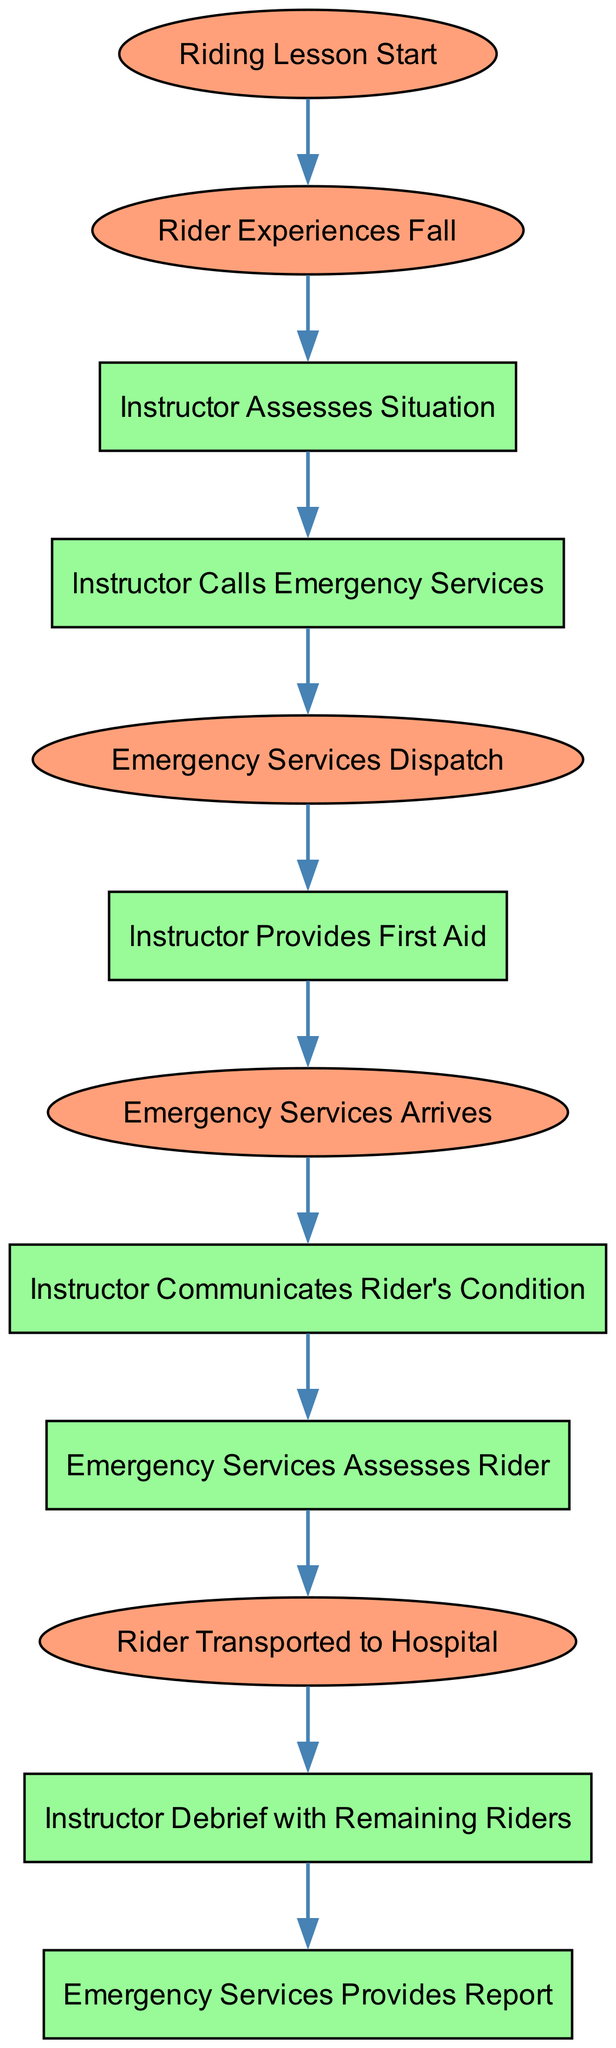What is the first event in the sequence? The first event in the sequence is labeled "Riding Lesson Start." It is the initial point where the process begins.
Answer: Riding Lesson Start How many actions are depicted in the diagram? By counting the elements labeled as actions, we find that there are six actions shown in the diagram.
Answer: 6 What occurs immediately after the instructor assesses the situation? Following the instructor assessing the situation, the next action is "Instructor Calls Emergency Services." This is the immediate next step in the sequence.
Answer: Instructor Calls Emergency Services Which action involves communication regarding the rider’s condition? The action that involves communication regarding the rider's condition is labeled "Instructor Communicates Rider's Condition." This step specifically addresses the need to report the condition to emergency services.
Answer: Instructor Communicates Rider's Condition How many events are there in total in this sequence diagram? By counting the nodes labeled as events, we see there are five events present in the sequence diagram.
Answer: 5 What action occurs before emergency services arrive? The action that occurs before emergency services arrive is "Emergency Services Dispatch." This action is crucial as it initiates the arrival of help.
Answer: Emergency Services Dispatch What is the last event in the sequence? The last event depicted in the sequence is "Emergency Services Provides Report," which indicates the end of the emergency response process.
Answer: Emergency Services Provides Report What happens immediately after the rider is transported to the hospital? The diagram does not indicate any further actions after the rider is transported to the hospital, as it ends at that event. Therefore, nothing follows that step.
Answer: Nothing Which action is taken by the instructor after providing first aid? After providing first aid, the next action taken by the instructor is "Emergency Services Arrives." This indicates the sequence of events leading to medical assistance.
Answer: Emergency Services Arrives 